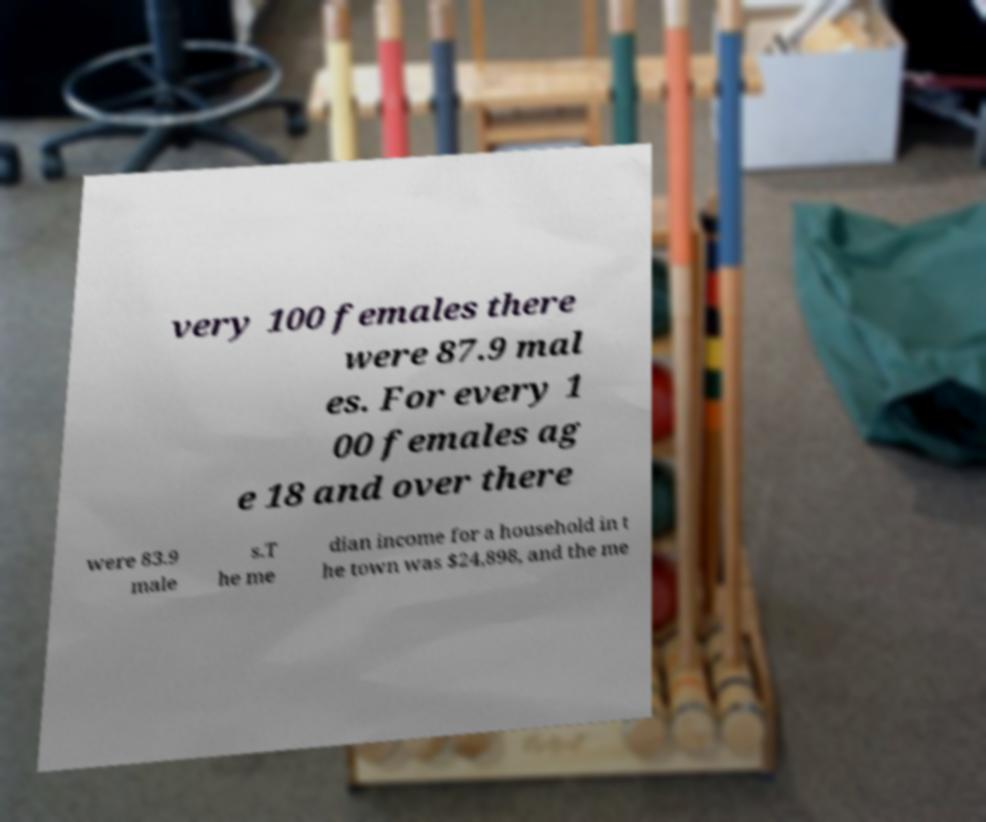Could you assist in decoding the text presented in this image and type it out clearly? very 100 females there were 87.9 mal es. For every 1 00 females ag e 18 and over there were 83.9 male s.T he me dian income for a household in t he town was $24,898, and the me 